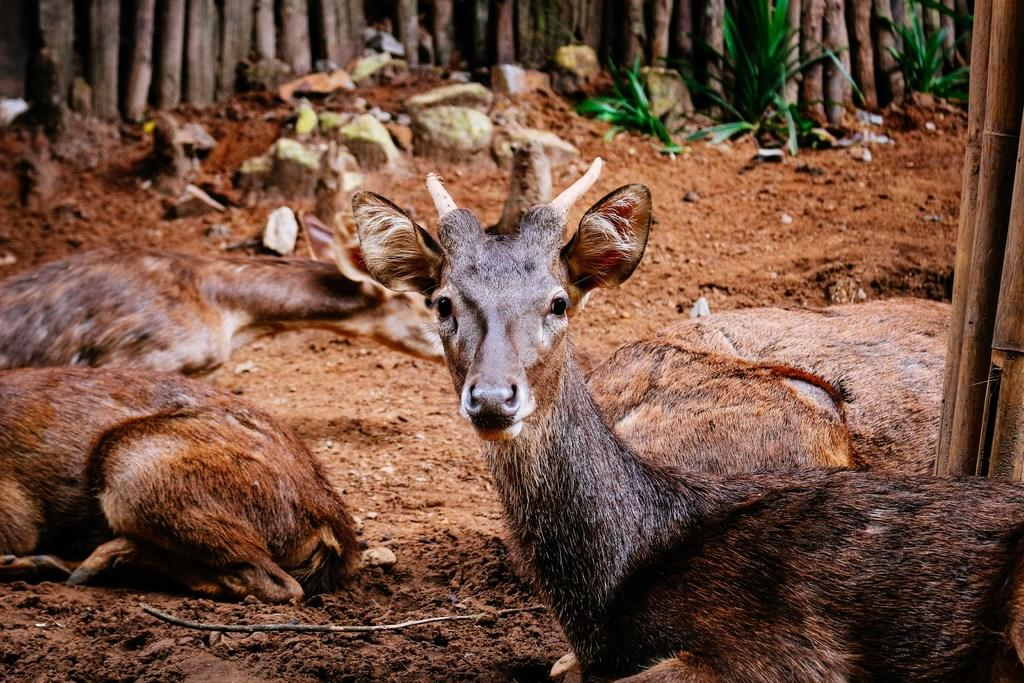What animals are on the ground in the image? There are deer on the ground in the image. What type of structures can be seen in the background of the image? There are wooden poles in the background of the image. What type of vegetation is visible in the background of the image? There are plants in the background of the image. What is the weight of the night in the image? There is no night present in the image, and therefore no weight can be attributed to it. 